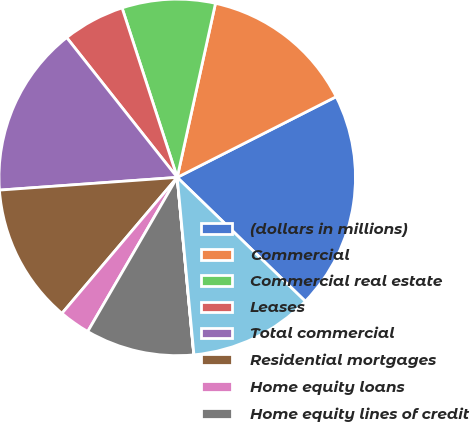Convert chart. <chart><loc_0><loc_0><loc_500><loc_500><pie_chart><fcel>(dollars in millions)<fcel>Commercial<fcel>Commercial real estate<fcel>Leases<fcel>Total commercial<fcel>Residential mortgages<fcel>Home equity loans<fcel>Home equity lines of credit<fcel>Home equity loans serviced by<fcel>Automobile<nl><fcel>19.71%<fcel>14.08%<fcel>8.45%<fcel>5.64%<fcel>15.49%<fcel>12.67%<fcel>2.82%<fcel>9.86%<fcel>0.01%<fcel>11.27%<nl></chart> 